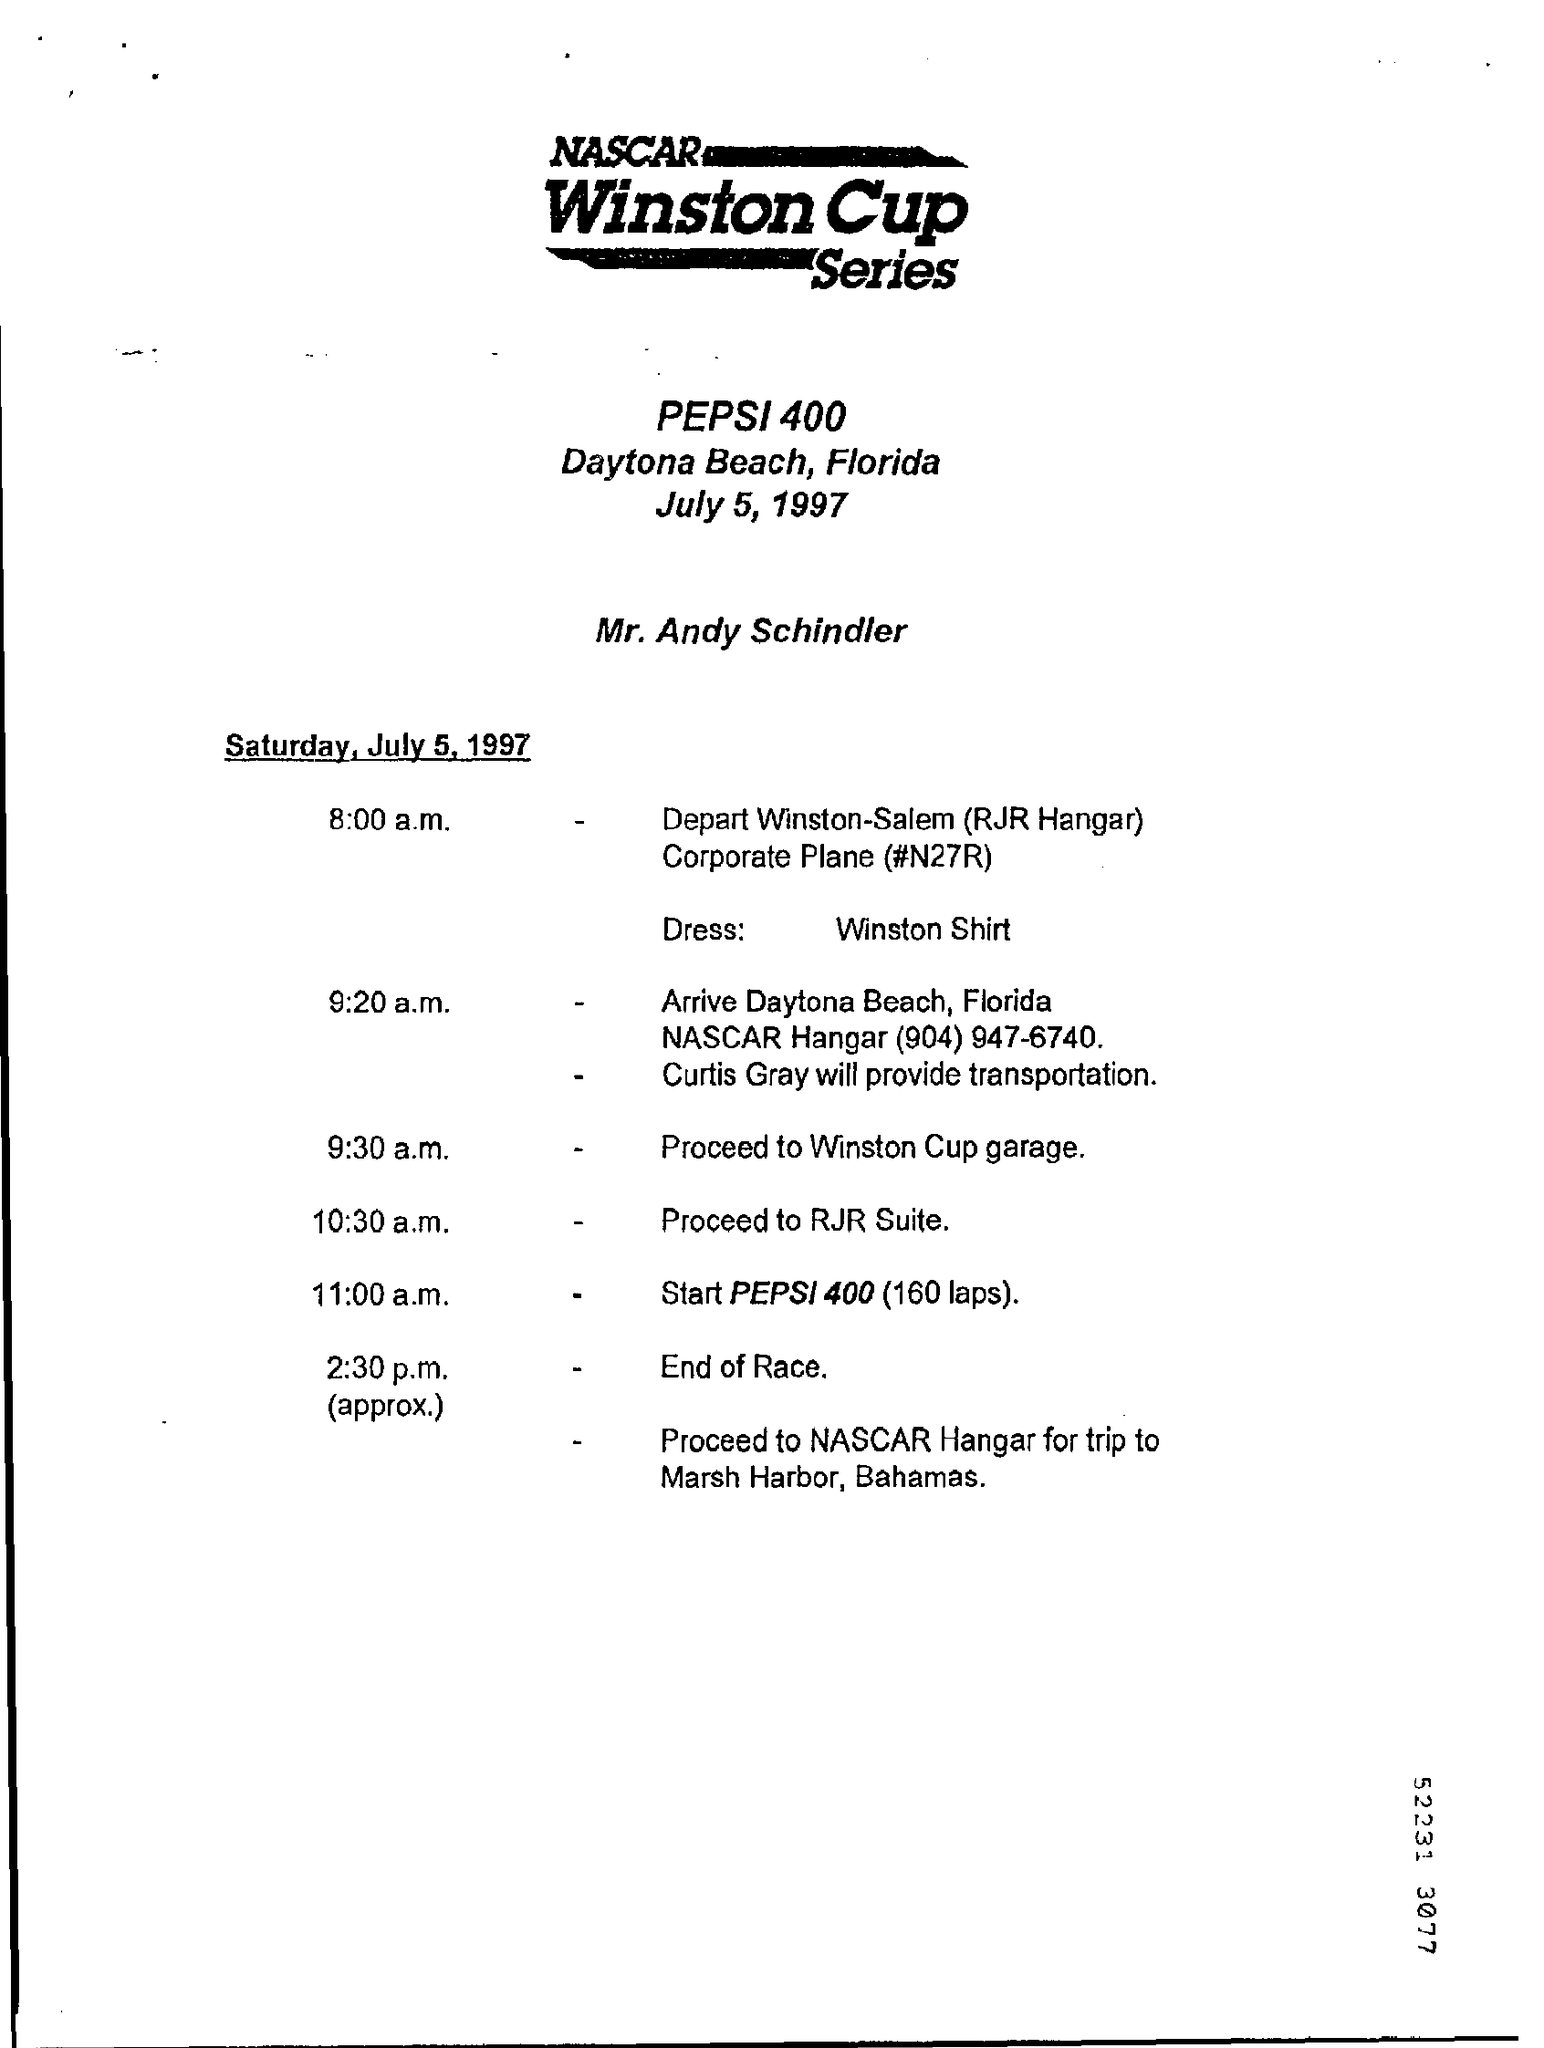Outline some significant characteristics in this image. At 11:00 a.m., there will be an event known as the Pepsi 400, which will consist of 160 laps. The race will take place in Daytona Beach, Florida. Curtis Gray will be responsible for providing transportation to the Winston Cup garage. The name of the person is Mr. Andy Schindler. The dress code for Winston Shirt is unknown. 